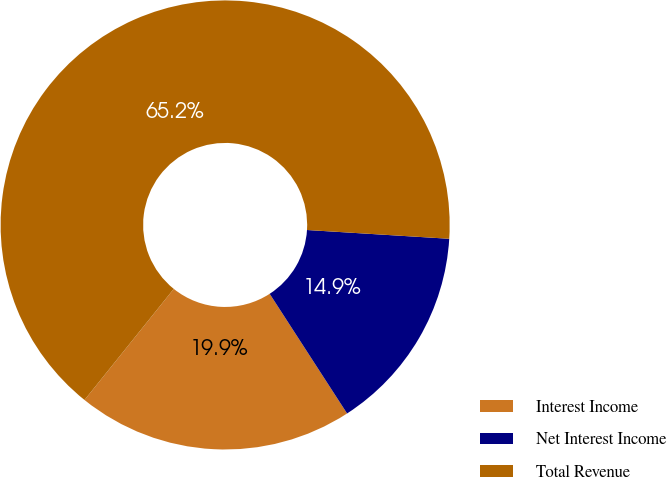Convert chart. <chart><loc_0><loc_0><loc_500><loc_500><pie_chart><fcel>Interest Income<fcel>Net Interest Income<fcel>Total Revenue<nl><fcel>19.91%<fcel>14.88%<fcel>65.21%<nl></chart> 